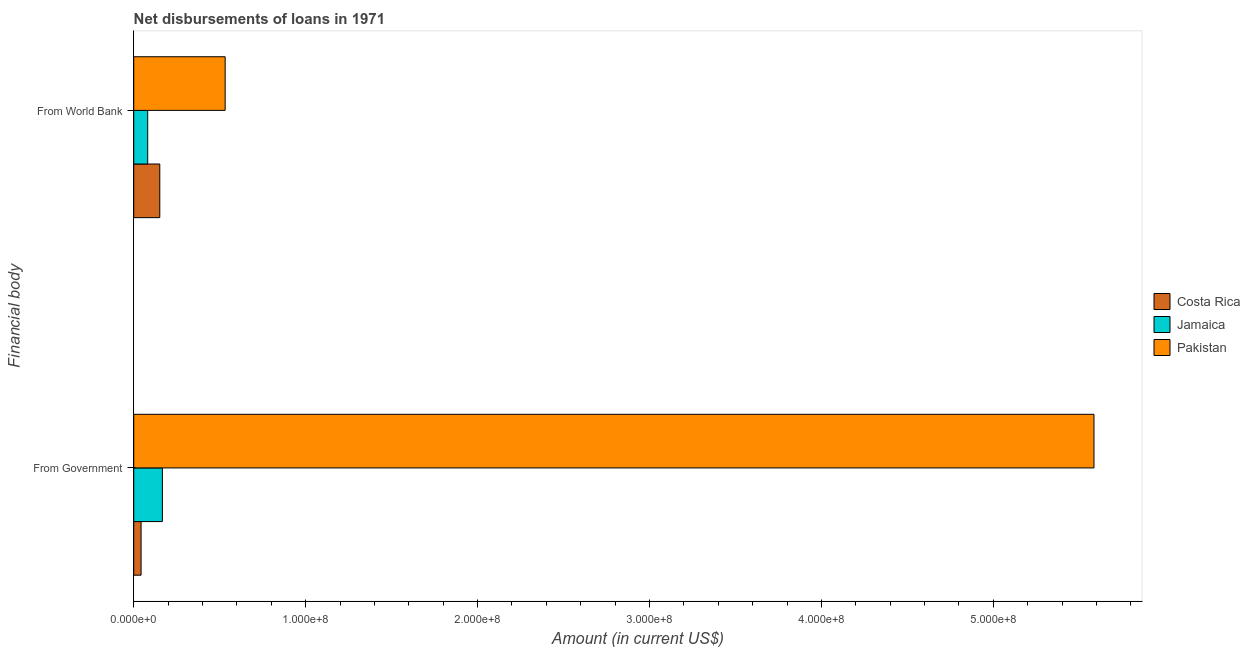How many different coloured bars are there?
Offer a very short reply. 3. Are the number of bars per tick equal to the number of legend labels?
Offer a terse response. Yes. How many bars are there on the 2nd tick from the top?
Make the answer very short. 3. What is the label of the 1st group of bars from the top?
Your answer should be compact. From World Bank. What is the net disbursements of loan from government in Jamaica?
Your answer should be compact. 1.67e+07. Across all countries, what is the maximum net disbursements of loan from government?
Your answer should be compact. 5.59e+08. Across all countries, what is the minimum net disbursements of loan from government?
Give a very brief answer. 4.27e+06. In which country was the net disbursements of loan from world bank minimum?
Offer a very short reply. Jamaica. What is the total net disbursements of loan from government in the graph?
Offer a terse response. 5.79e+08. What is the difference between the net disbursements of loan from government in Pakistan and that in Costa Rica?
Give a very brief answer. 5.54e+08. What is the difference between the net disbursements of loan from world bank in Jamaica and the net disbursements of loan from government in Pakistan?
Provide a short and direct response. -5.50e+08. What is the average net disbursements of loan from government per country?
Provide a succinct answer. 1.93e+08. What is the difference between the net disbursements of loan from world bank and net disbursements of loan from government in Costa Rica?
Ensure brevity in your answer.  1.09e+07. What is the ratio of the net disbursements of loan from world bank in Pakistan to that in Costa Rica?
Offer a terse response. 3.51. What does the 1st bar from the top in From World Bank represents?
Offer a very short reply. Pakistan. What does the 3rd bar from the bottom in From Government represents?
Offer a terse response. Pakistan. Are all the bars in the graph horizontal?
Your answer should be very brief. Yes. Are the values on the major ticks of X-axis written in scientific E-notation?
Give a very brief answer. Yes. Does the graph contain any zero values?
Provide a succinct answer. No. Where does the legend appear in the graph?
Provide a succinct answer. Center right. How many legend labels are there?
Offer a very short reply. 3. What is the title of the graph?
Offer a very short reply. Net disbursements of loans in 1971. What is the label or title of the X-axis?
Give a very brief answer. Amount (in current US$). What is the label or title of the Y-axis?
Ensure brevity in your answer.  Financial body. What is the Amount (in current US$) in Costa Rica in From Government?
Offer a very short reply. 4.27e+06. What is the Amount (in current US$) of Jamaica in From Government?
Give a very brief answer. 1.67e+07. What is the Amount (in current US$) in Pakistan in From Government?
Your answer should be compact. 5.59e+08. What is the Amount (in current US$) in Costa Rica in From World Bank?
Your answer should be compact. 1.52e+07. What is the Amount (in current US$) of Jamaica in From World Bank?
Your answer should be compact. 8.12e+06. What is the Amount (in current US$) of Pakistan in From World Bank?
Offer a very short reply. 5.32e+07. Across all Financial body, what is the maximum Amount (in current US$) in Costa Rica?
Ensure brevity in your answer.  1.52e+07. Across all Financial body, what is the maximum Amount (in current US$) in Jamaica?
Your answer should be compact. 1.67e+07. Across all Financial body, what is the maximum Amount (in current US$) of Pakistan?
Your answer should be compact. 5.59e+08. Across all Financial body, what is the minimum Amount (in current US$) in Costa Rica?
Your answer should be very brief. 4.27e+06. Across all Financial body, what is the minimum Amount (in current US$) in Jamaica?
Your answer should be very brief. 8.12e+06. Across all Financial body, what is the minimum Amount (in current US$) in Pakistan?
Give a very brief answer. 5.32e+07. What is the total Amount (in current US$) of Costa Rica in the graph?
Your answer should be very brief. 1.94e+07. What is the total Amount (in current US$) in Jamaica in the graph?
Provide a succinct answer. 2.48e+07. What is the total Amount (in current US$) of Pakistan in the graph?
Your response must be concise. 6.12e+08. What is the difference between the Amount (in current US$) in Costa Rica in From Government and that in From World Bank?
Provide a short and direct response. -1.09e+07. What is the difference between the Amount (in current US$) in Jamaica in From Government and that in From World Bank?
Provide a succinct answer. 8.54e+06. What is the difference between the Amount (in current US$) in Pakistan in From Government and that in From World Bank?
Keep it short and to the point. 5.05e+08. What is the difference between the Amount (in current US$) in Costa Rica in From Government and the Amount (in current US$) in Jamaica in From World Bank?
Ensure brevity in your answer.  -3.86e+06. What is the difference between the Amount (in current US$) of Costa Rica in From Government and the Amount (in current US$) of Pakistan in From World Bank?
Ensure brevity in your answer.  -4.89e+07. What is the difference between the Amount (in current US$) of Jamaica in From Government and the Amount (in current US$) of Pakistan in From World Bank?
Ensure brevity in your answer.  -3.65e+07. What is the average Amount (in current US$) of Costa Rica per Financial body?
Offer a very short reply. 9.71e+06. What is the average Amount (in current US$) in Jamaica per Financial body?
Your response must be concise. 1.24e+07. What is the average Amount (in current US$) in Pakistan per Financial body?
Your answer should be compact. 3.06e+08. What is the difference between the Amount (in current US$) in Costa Rica and Amount (in current US$) in Jamaica in From Government?
Make the answer very short. -1.24e+07. What is the difference between the Amount (in current US$) in Costa Rica and Amount (in current US$) in Pakistan in From Government?
Make the answer very short. -5.54e+08. What is the difference between the Amount (in current US$) of Jamaica and Amount (in current US$) of Pakistan in From Government?
Your answer should be very brief. -5.42e+08. What is the difference between the Amount (in current US$) of Costa Rica and Amount (in current US$) of Jamaica in From World Bank?
Offer a very short reply. 7.03e+06. What is the difference between the Amount (in current US$) of Costa Rica and Amount (in current US$) of Pakistan in From World Bank?
Make the answer very short. -3.80e+07. What is the difference between the Amount (in current US$) of Jamaica and Amount (in current US$) of Pakistan in From World Bank?
Your answer should be compact. -4.50e+07. What is the ratio of the Amount (in current US$) of Costa Rica in From Government to that in From World Bank?
Your answer should be very brief. 0.28. What is the ratio of the Amount (in current US$) in Jamaica in From Government to that in From World Bank?
Your answer should be very brief. 2.05. What is the ratio of the Amount (in current US$) in Pakistan in From Government to that in From World Bank?
Offer a very short reply. 10.5. What is the difference between the highest and the second highest Amount (in current US$) in Costa Rica?
Ensure brevity in your answer.  1.09e+07. What is the difference between the highest and the second highest Amount (in current US$) in Jamaica?
Keep it short and to the point. 8.54e+06. What is the difference between the highest and the second highest Amount (in current US$) of Pakistan?
Keep it short and to the point. 5.05e+08. What is the difference between the highest and the lowest Amount (in current US$) in Costa Rica?
Make the answer very short. 1.09e+07. What is the difference between the highest and the lowest Amount (in current US$) in Jamaica?
Ensure brevity in your answer.  8.54e+06. What is the difference between the highest and the lowest Amount (in current US$) in Pakistan?
Give a very brief answer. 5.05e+08. 